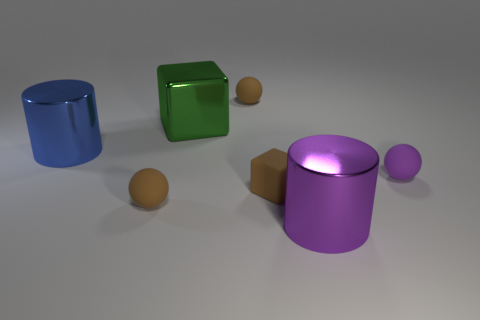Add 1 blue metal cylinders. How many objects exist? 8 Subtract all balls. How many objects are left? 4 Add 4 purple spheres. How many purple spheres are left? 5 Add 1 small matte things. How many small matte things exist? 5 Subtract 0 blue balls. How many objects are left? 7 Subtract all big cylinders. Subtract all large matte blocks. How many objects are left? 5 